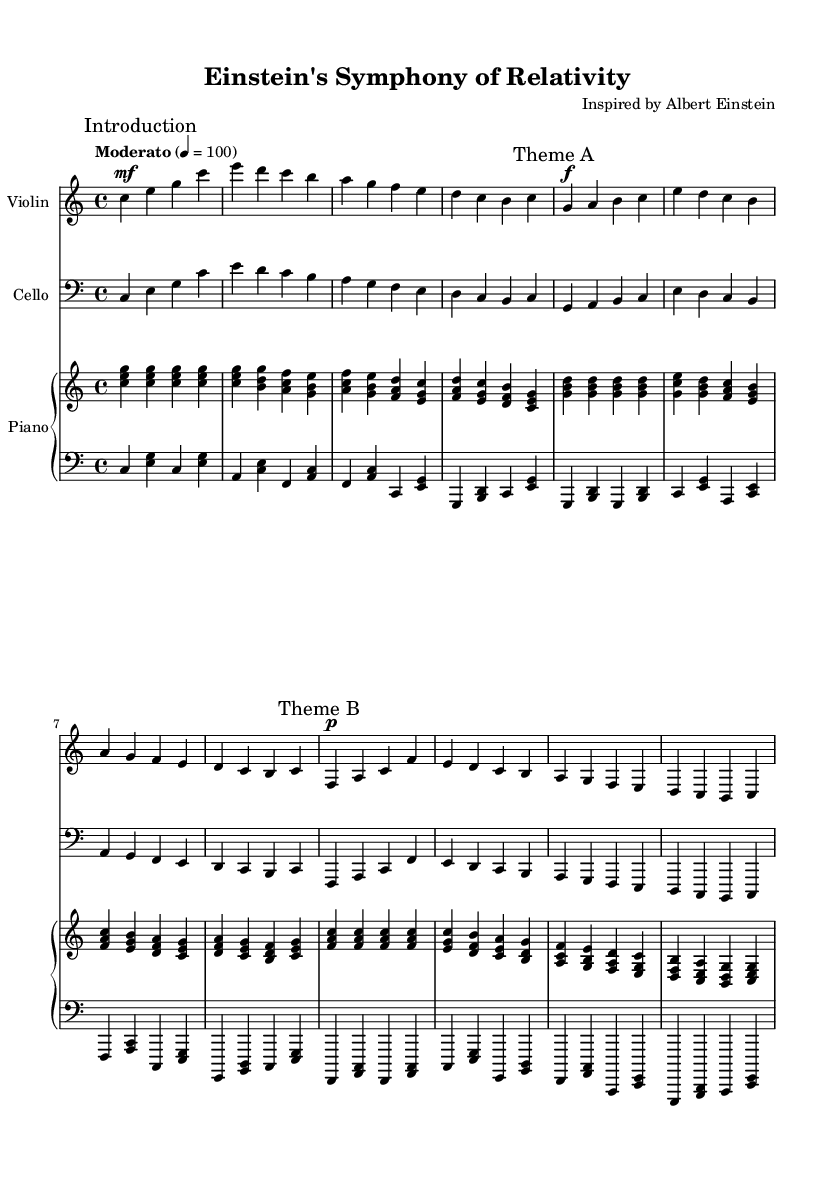What is the key signature of this music? The key signature is indicated at the beginning of the score. In this case, it shows no sharps or flats, corresponding to the key of C major.
Answer: C major What is the time signature of the piece? The time signature appears at the beginning of the score. Here, it is written as 4/4, indicating four beats per measure, with a quarter note receiving one beat.
Answer: 4/4 What is the tempo marking for this piece? The tempo marking is noted in the score above the staff, specifically labeled as "Moderato," with a metronome marking of quarter note = 100, indicating a moderately brisk tempo.
Answer: Moderato How many themes are presented in the composition? By analyzing the sections marked in the sheet music, there are sections designated as "Theme A" and "Theme B." Counting these, we find two themes.
Answer: 2 What is the dynamics marking for Theme A? The music shows dynamics markings next to the section labeled "Theme A." Here, it is indicated as forte (f), meaning to play loudly.
Answer: forte What instruments are featured in this piece? The score indicates three parts; the title above lists "Violin," "Cello," and "Piano," clearly showing the instruments involved in the composition.
Answer: Violin, Cello, Piano What phrase marks the beginning of the score? The score begins with the section marked "Introduction," indicating the opening phrase of the composition before any themes are introduced.
Answer: Introduction 